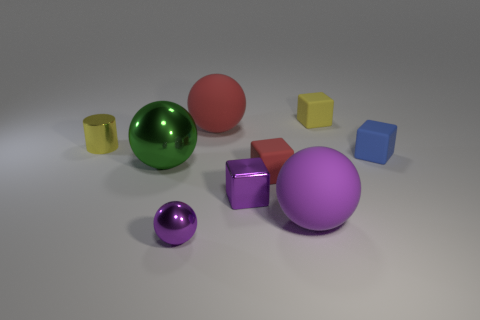There is a big rubber ball that is left of the small block that is on the left side of the matte block that is to the left of the yellow cube; what color is it?
Provide a short and direct response. Red. How many big objects are red spheres or matte spheres?
Provide a succinct answer. 2. Are there an equal number of purple things that are behind the tiny yellow rubber block and cyan metal spheres?
Make the answer very short. Yes. There is a small purple metal ball; are there any small red cubes to the right of it?
Provide a succinct answer. Yes. How many rubber things are large objects or big cylinders?
Your response must be concise. 2. What number of shiny cylinders are behind the big metallic sphere?
Your answer should be very brief. 1. Are there any purple metallic balls that have the same size as the metallic cube?
Provide a succinct answer. Yes. Is there a metallic ball of the same color as the tiny metallic block?
Give a very brief answer. Yes. How many big spheres are the same color as the small metal ball?
Offer a very short reply. 1. Does the metal cylinder have the same color as the tiny block that is behind the blue cube?
Offer a terse response. Yes. 